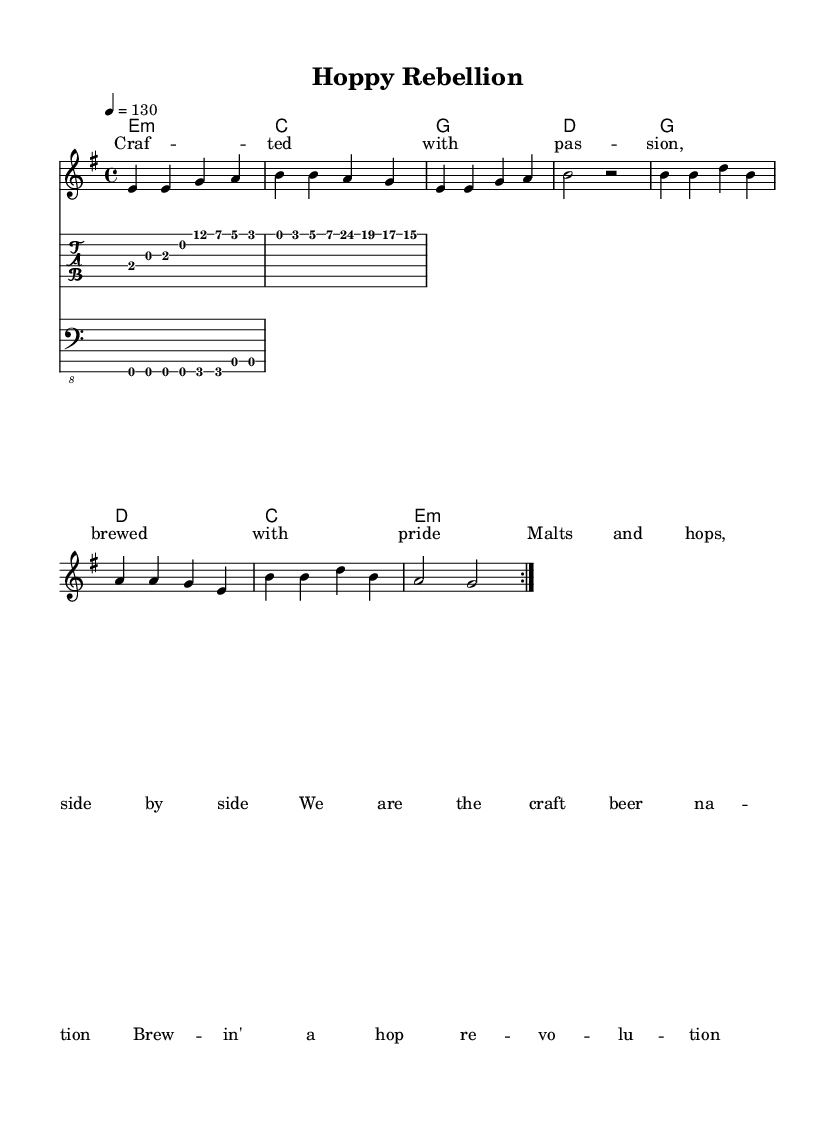What is the key signature of this music? The key signature is E minor, which has one sharp (F#). This can be identified by looking at the key signature indicated at the beginning of the staff.
Answer: E minor What is the time signature of this music? The time signature is 4/4, which is shown at the beginning of the score. It indicates that there are four beats in each measure and a quarter note gets one beat.
Answer: 4/4 What is the tempo marking of the piece? The tempo marking is 130 beats per minute, noted above the staff. This indicates the speed at which the piece should be played.
Answer: 130 How many measures are repeated in the melody? The melody contains two measures that are repeated, as indicated by the "repeat volta 2" notation at the beginning of the melody section.
Answer: 2 What is the main theme of the lyrics? The main theme of the lyrics revolves around the pride and passion of craft beer brewing, emphasizing the community and revolution behind it. This can be deduced by reading the lyrics provided below the melody.
Answer: Craft beer revolution What type of music does this piece represent? This piece represents hard rock, which is evident from the energetic riffs and chord progressions typically associated with the genre, as well as the lyrical theme celebrating craft beer culture.
Answer: Hard rock What type of instruments are used in this score? The score includes a melody staff for vocals, chords for harmonic support, a guitar tab staff for the guitar, and a bass tab staff for the bassline. Each component contributes to the overall hard rock sound.
Answer: Vocals, guitar, bass 